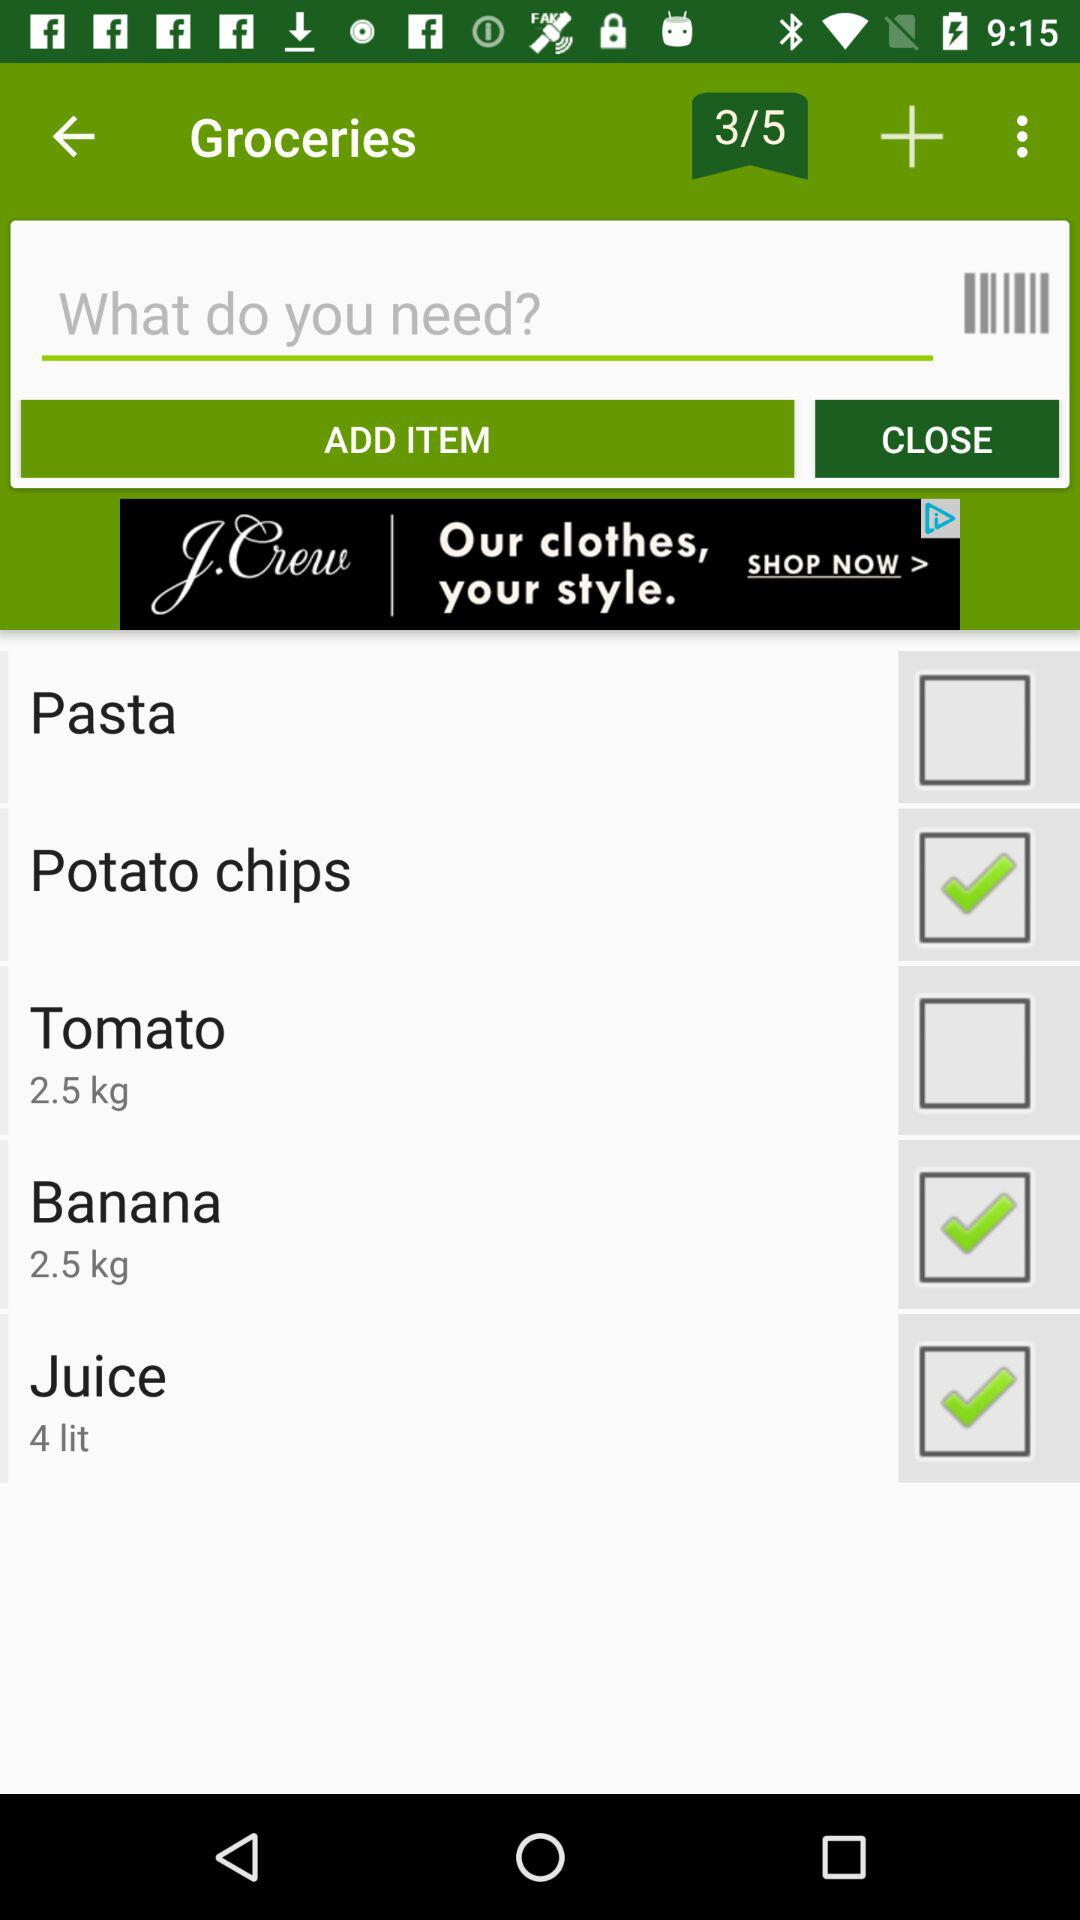Is "Pasta" checked or not?
Answer the question using a single word or phrase. "Pasta" is unchecked. 